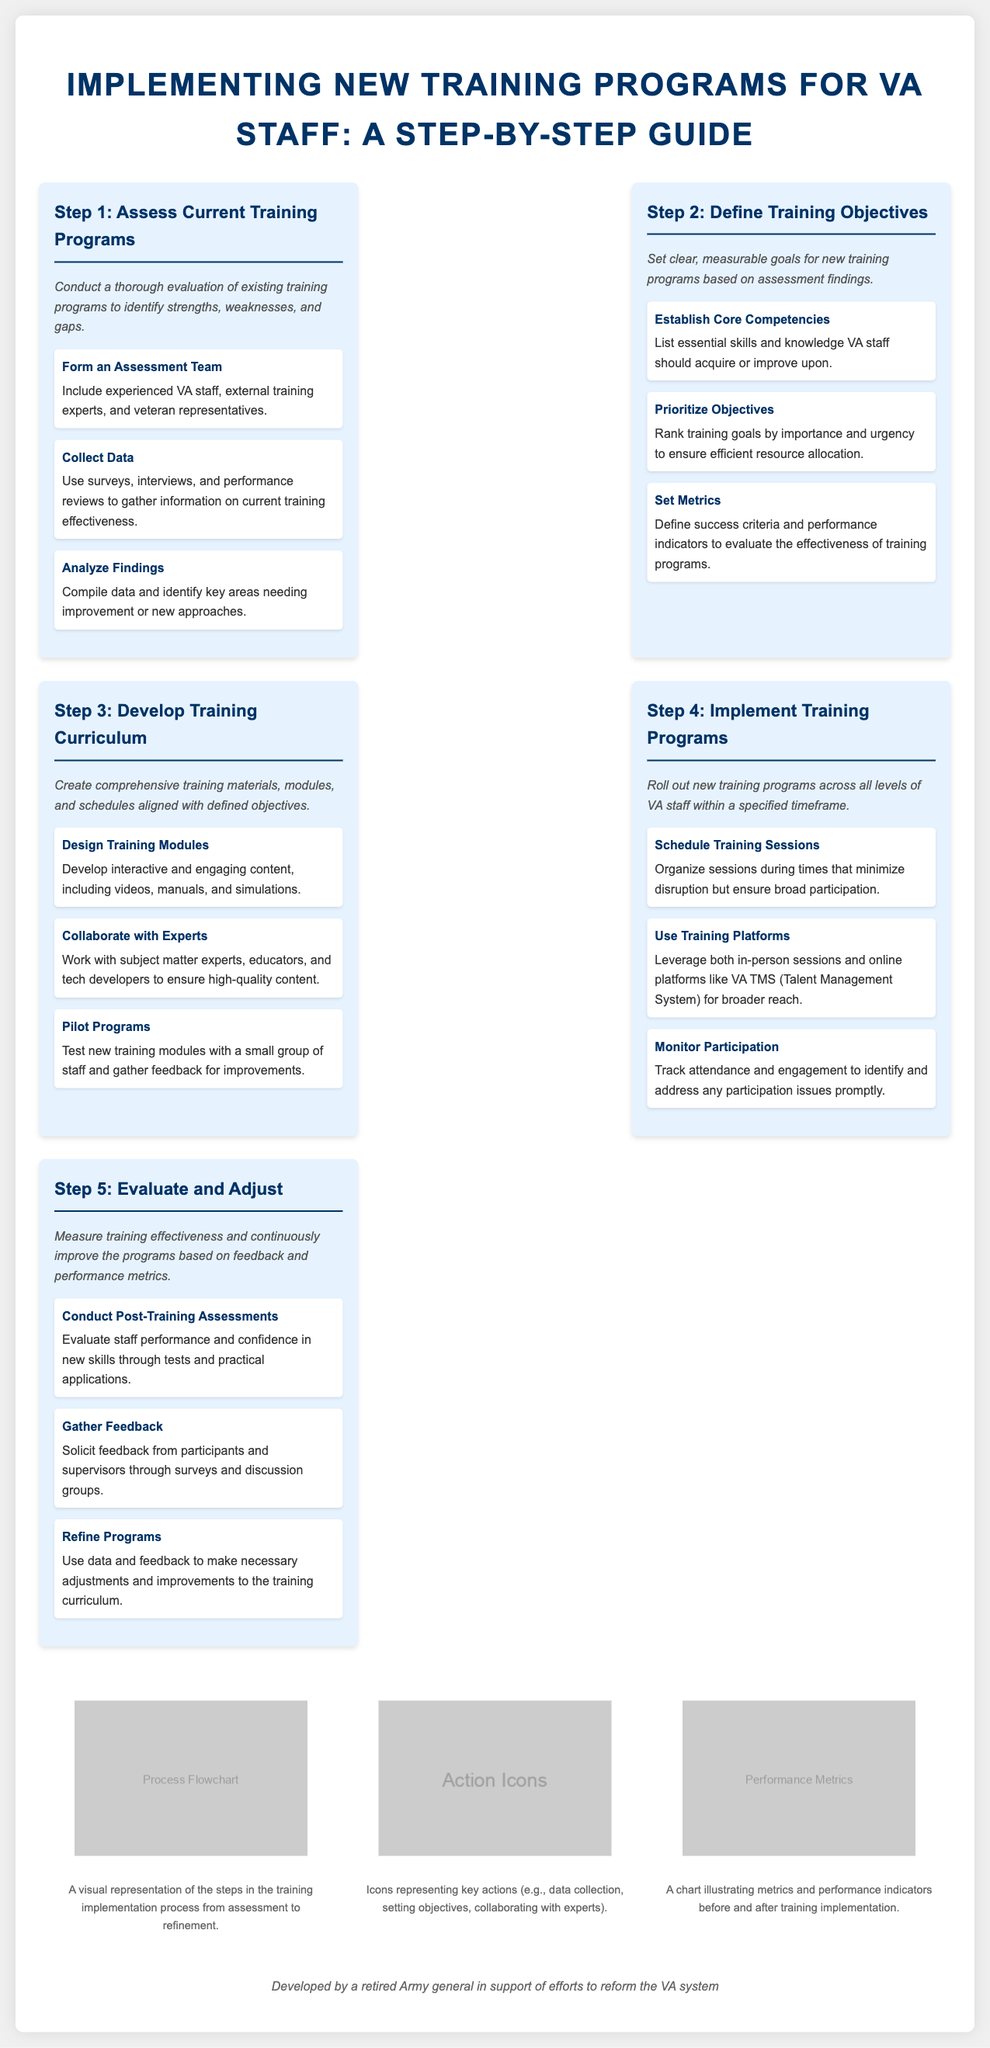what is the title of the document? The title of the document is presented at the top of the infographic.
Answer: Implementing New Training Programs for VA Staff: A Step-by-Step Guide how many steps are there in the training implementation process? The steps are listed sequentially in the process steps section.
Answer: 5 what is step 4 in the process? The steps are defined and labeled clearly in the infographic.
Answer: Implement Training Programs which team should be formed in step 1? Step 1 highlights the formation of a specific team tasked with assessment.
Answer: Assessment Team what action is taken in step 3 regarding training curriculum? Each step outlines key actions to be taken, including the development of curriculum.
Answer: Develop training materials what should be analyzed in step 1? The first step emphasizes the evaluation of a particular aspect of training.
Answer: Existing training programs what is the purpose of gathering feedback in step 5? Feedback collection is mentioned as a critical component for continuous improvement.
Answer: Improve the programs which platform is suggested for training in step 4? Step 4 mentions specific training methodologies and platforms to be utilized.
Answer: VA TMS how are training objectives prioritized in step 2? The process emphasizes ranking training goals in a particular way.
Answer: By importance and urgency 